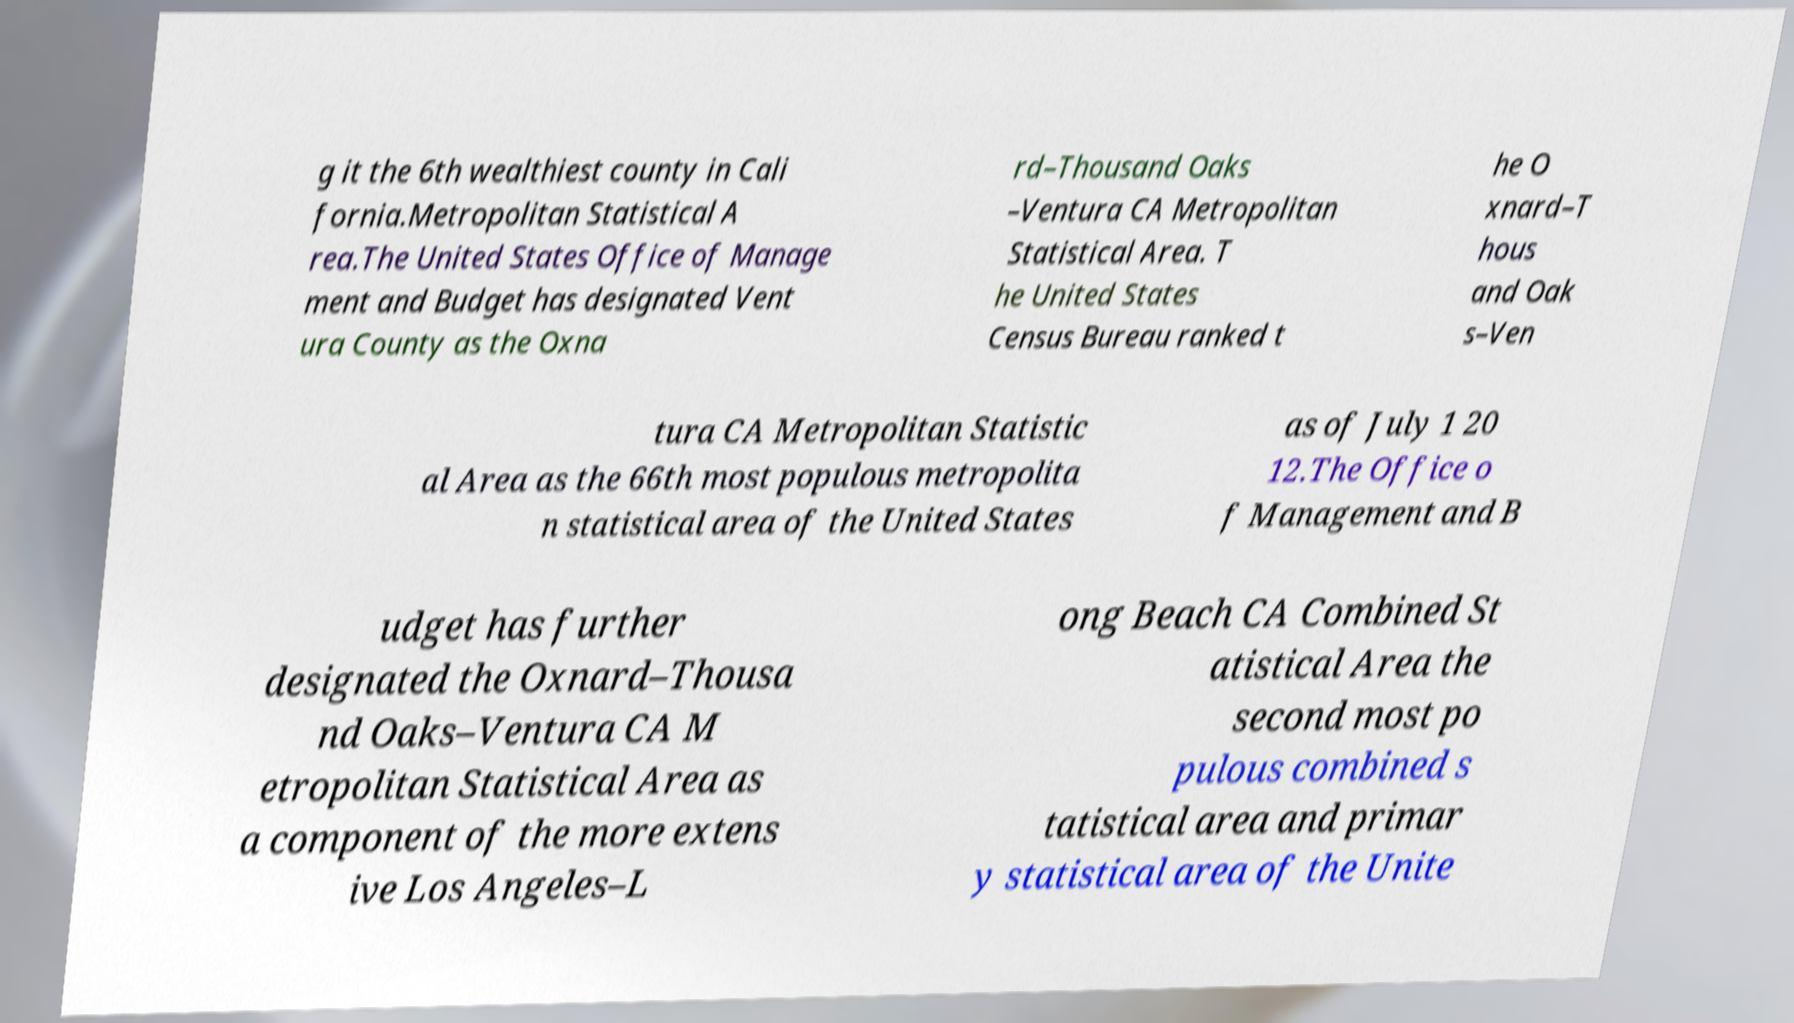Please read and relay the text visible in this image. What does it say? g it the 6th wealthiest county in Cali fornia.Metropolitan Statistical A rea.The United States Office of Manage ment and Budget has designated Vent ura County as the Oxna rd–Thousand Oaks –Ventura CA Metropolitan Statistical Area. T he United States Census Bureau ranked t he O xnard–T hous and Oak s–Ven tura CA Metropolitan Statistic al Area as the 66th most populous metropolita n statistical area of the United States as of July 1 20 12.The Office o f Management and B udget has further designated the Oxnard–Thousa nd Oaks–Ventura CA M etropolitan Statistical Area as a component of the more extens ive Los Angeles–L ong Beach CA Combined St atistical Area the second most po pulous combined s tatistical area and primar y statistical area of the Unite 